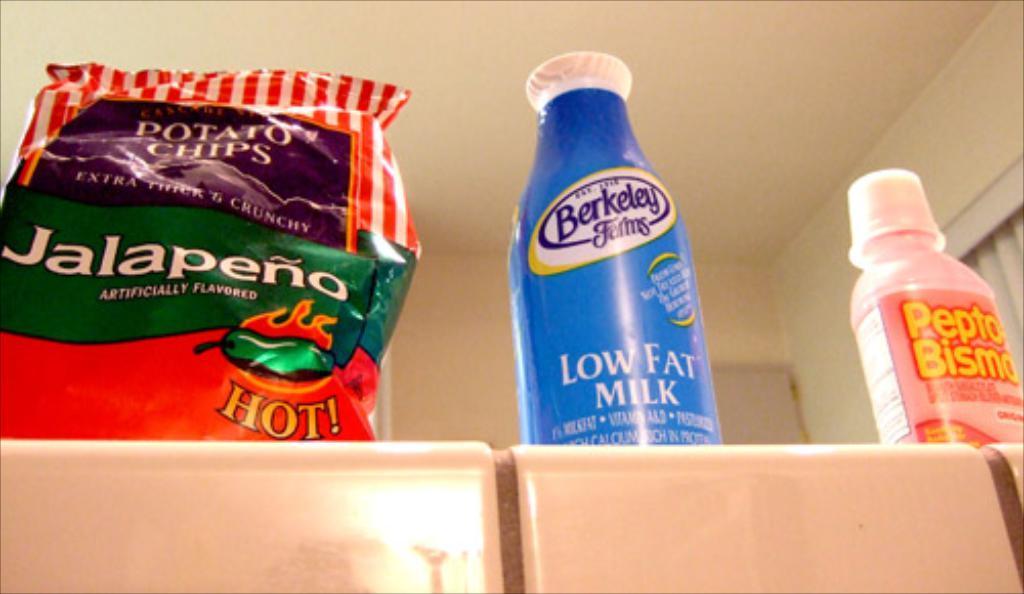How would you summarize this image in a sentence or two? In this image two bottles are kept and one potato chips packet is kept on the table. In front of that three chairs are visible which are light brown in color. The rooftop is light brown in color. This image is taken inside the house. 